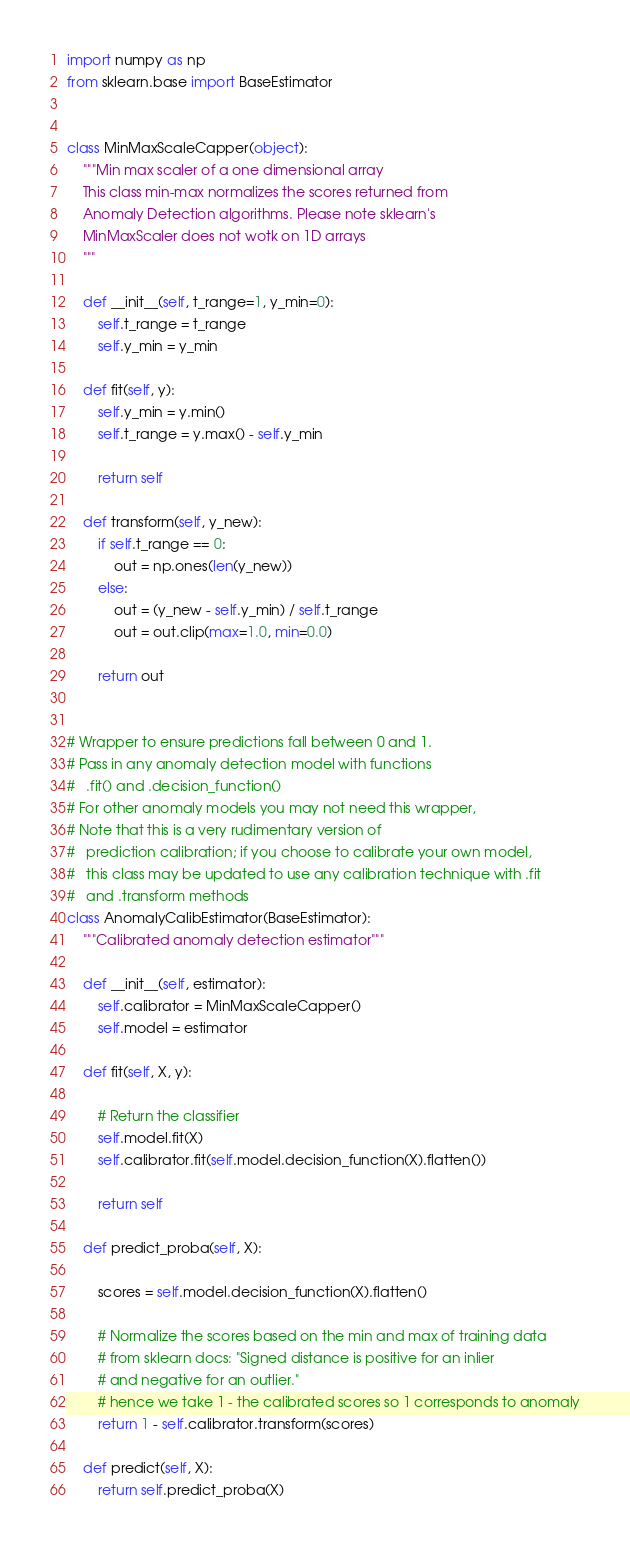<code> <loc_0><loc_0><loc_500><loc_500><_Python_>import numpy as np
from sklearn.base import BaseEstimator


class MinMaxScaleCapper(object):
    """Min max scaler of a one dimensional array
    This class min-max normalizes the scores returned from
    Anomaly Detection algorithms. Please note sklearn's
    MinMaxScaler does not wotk on 1D arrays
    """

    def __init__(self, t_range=1, y_min=0):
        self.t_range = t_range
        self.y_min = y_min

    def fit(self, y):
        self.y_min = y.min()
        self.t_range = y.max() - self.y_min

        return self

    def transform(self, y_new):
        if self.t_range == 0:
            out = np.ones(len(y_new))
        else:
            out = (y_new - self.y_min) / self.t_range
            out = out.clip(max=1.0, min=0.0)

        return out


# Wrapper to ensure predictions fall between 0 and 1.
# Pass in any anomaly detection model with functions
# 	.fit() and .decision_function()
# For other anomaly models you may not need this wrapper,
# Note that this is a very rudimentary version of
# 	prediction calibration; if you choose to calibrate your own model,
# 	this class may be updated to use any calibration technique with .fit
# 	and .transform methods
class AnomalyCalibEstimator(BaseEstimator):
    """Calibrated anomaly detection estimator"""

    def __init__(self, estimator):
        self.calibrator = MinMaxScaleCapper()
        self.model = estimator

    def fit(self, X, y):

        # Return the classifier
        self.model.fit(X)
        self.calibrator.fit(self.model.decision_function(X).flatten())

        return self

    def predict_proba(self, X):

        scores = self.model.decision_function(X).flatten()

        # Normalize the scores based on the min and max of training data
        # from sklearn docs: "Signed distance is positive for an inlier
        # and negative for an outlier."
        # hence we take 1 - the calibrated scores so 1 corresponds to anomaly
        return 1 - self.calibrator.transform(scores)

    def predict(self, X):
        return self.predict_proba(X)
</code> 